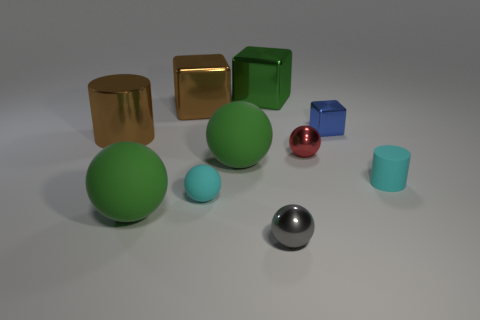Are the cyan thing left of the blue metal object and the brown block made of the same material?
Offer a terse response. No. The green object that is behind the brown block has what shape?
Give a very brief answer. Cube. There is a cylinder that is the same size as the green metal object; what is its material?
Give a very brief answer. Metal. What number of things are small matte objects on the left side of the gray object or big balls that are behind the cyan ball?
Provide a succinct answer. 2. What size is the cylinder that is made of the same material as the cyan sphere?
Your answer should be very brief. Small. How many shiny objects are cyan things or blue objects?
Keep it short and to the point. 1. The gray metallic sphere has what size?
Offer a very short reply. Small. Do the gray metal ball and the blue shiny cube have the same size?
Ensure brevity in your answer.  Yes. What is the material of the small cyan object that is to the left of the tiny cyan cylinder?
Provide a short and direct response. Rubber. What is the material of the green thing that is the same shape as the blue thing?
Offer a very short reply. Metal. 